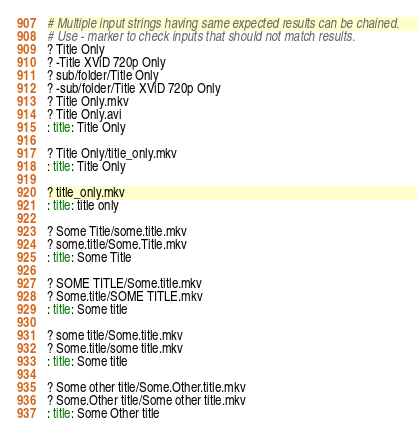Convert code to text. <code><loc_0><loc_0><loc_500><loc_500><_YAML_># Multiple input strings having same expected results can be chained.
# Use - marker to check inputs that should not match results.
? Title Only
? -Title XViD 720p Only
? sub/folder/Title Only
? -sub/folder/Title XViD 720p Only
? Title Only.mkv
? Title Only.avi
: title: Title Only

? Title Only/title_only.mkv
: title: Title Only

? title_only.mkv
: title: title only

? Some Title/some.title.mkv
? some.title/Some.Title.mkv
: title: Some Title

? SOME TITLE/Some.title.mkv
? Some.title/SOME TITLE.mkv
: title: Some title

? some title/Some.title.mkv
? Some.title/some title.mkv
: title: Some title

? Some other title/Some.Other.title.mkv
? Some.Other title/Some other title.mkv
: title: Some Other title

</code> 